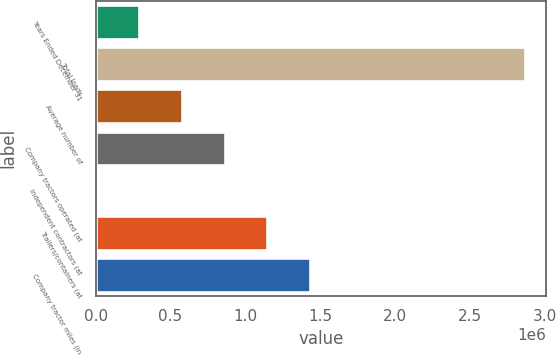<chart> <loc_0><loc_0><loc_500><loc_500><bar_chart><fcel>Years Ended December 31<fcel>Total loads<fcel>Average number of<fcel>Company tractors operated (at<fcel>Independent contractors (at<fcel>Trailers/containers (at<fcel>Company tractor miles (in<nl><fcel>287783<fcel>2.86604e+06<fcel>574257<fcel>860730<fcel>1310<fcel>1.1472e+06<fcel>1.43368e+06<nl></chart> 